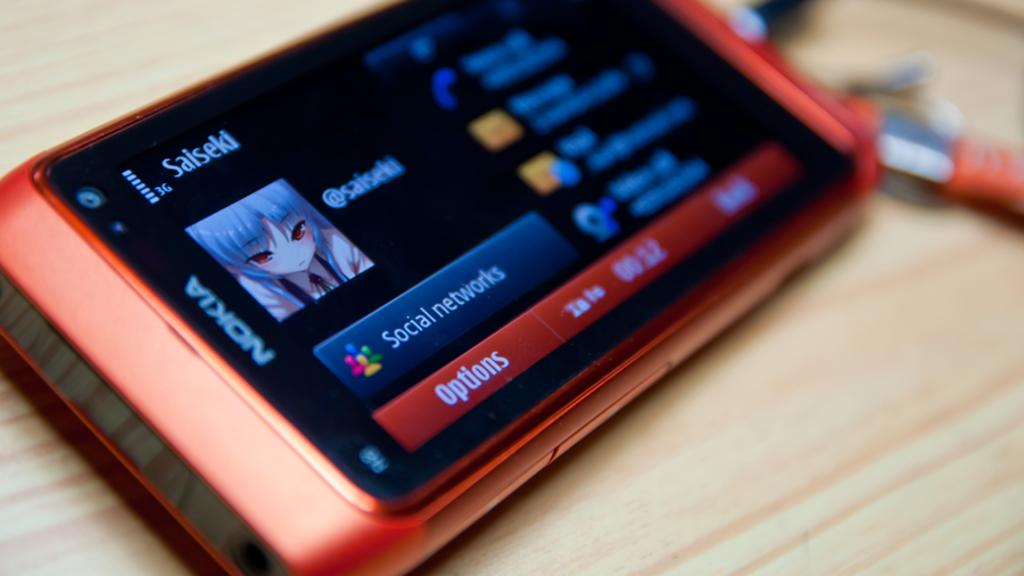<image>
Share a concise interpretation of the image provided. A Nokia hanheld device has a screen showing a sinister cartoon icon above a blue bar saying social networks.. 